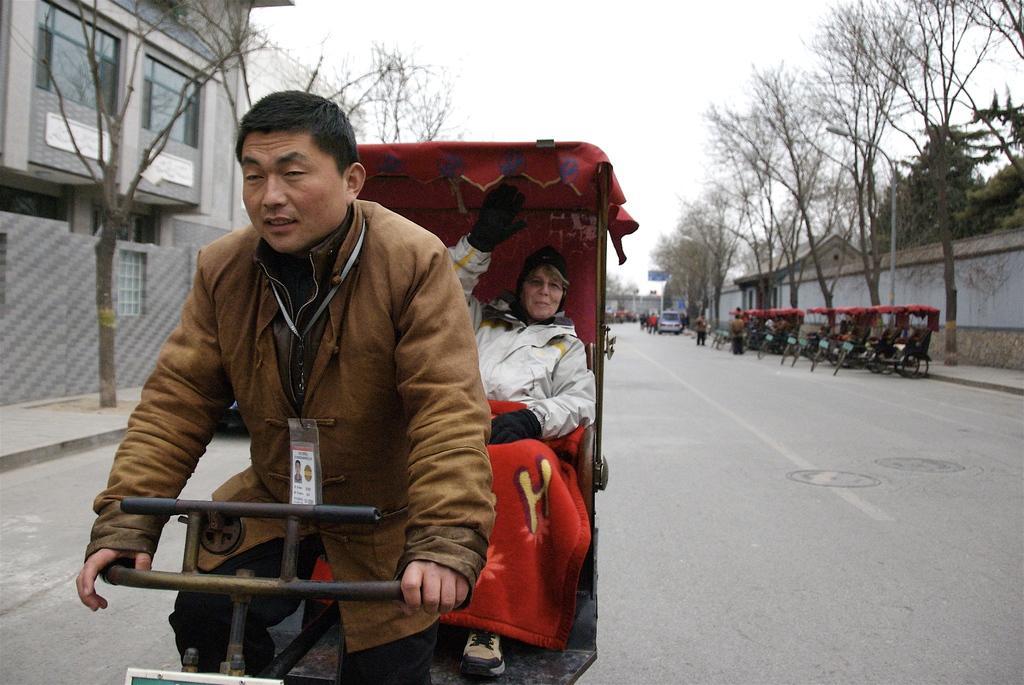Describe this image in one or two sentences. In the background we can see the sky, people and a vehicle. In this picture we can see a building, windows and boards. On either side of the road we can see the trees. We can see the pedicabs on the right side of the picture. In this picture we can see a man riding a pedicab and a woman is sitting behind him. 